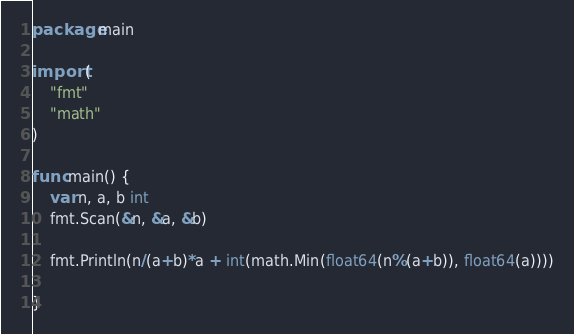Convert code to text. <code><loc_0><loc_0><loc_500><loc_500><_Go_>package main

import (
	"fmt"
	"math"
)

func main() {
	var n, a, b int
	fmt.Scan(&n, &a, &b)

	fmt.Println(n/(a+b)*a + int(math.Min(float64(n%(a+b)), float64(a))))

}
</code> 